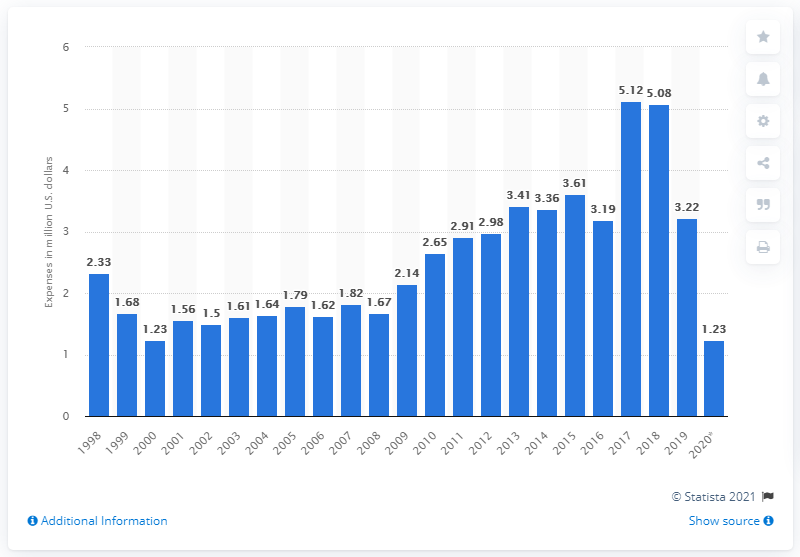Highlight a few significant elements in this photo. As of June 2020, the National Rifle Association (NRA) had spent a total of $1,230,000 on lobbying efforts. The National Rifle Association (NRA) incurred an expenditure of approximately $1.23 million on lobbying efforts between 2017 and 2018. 